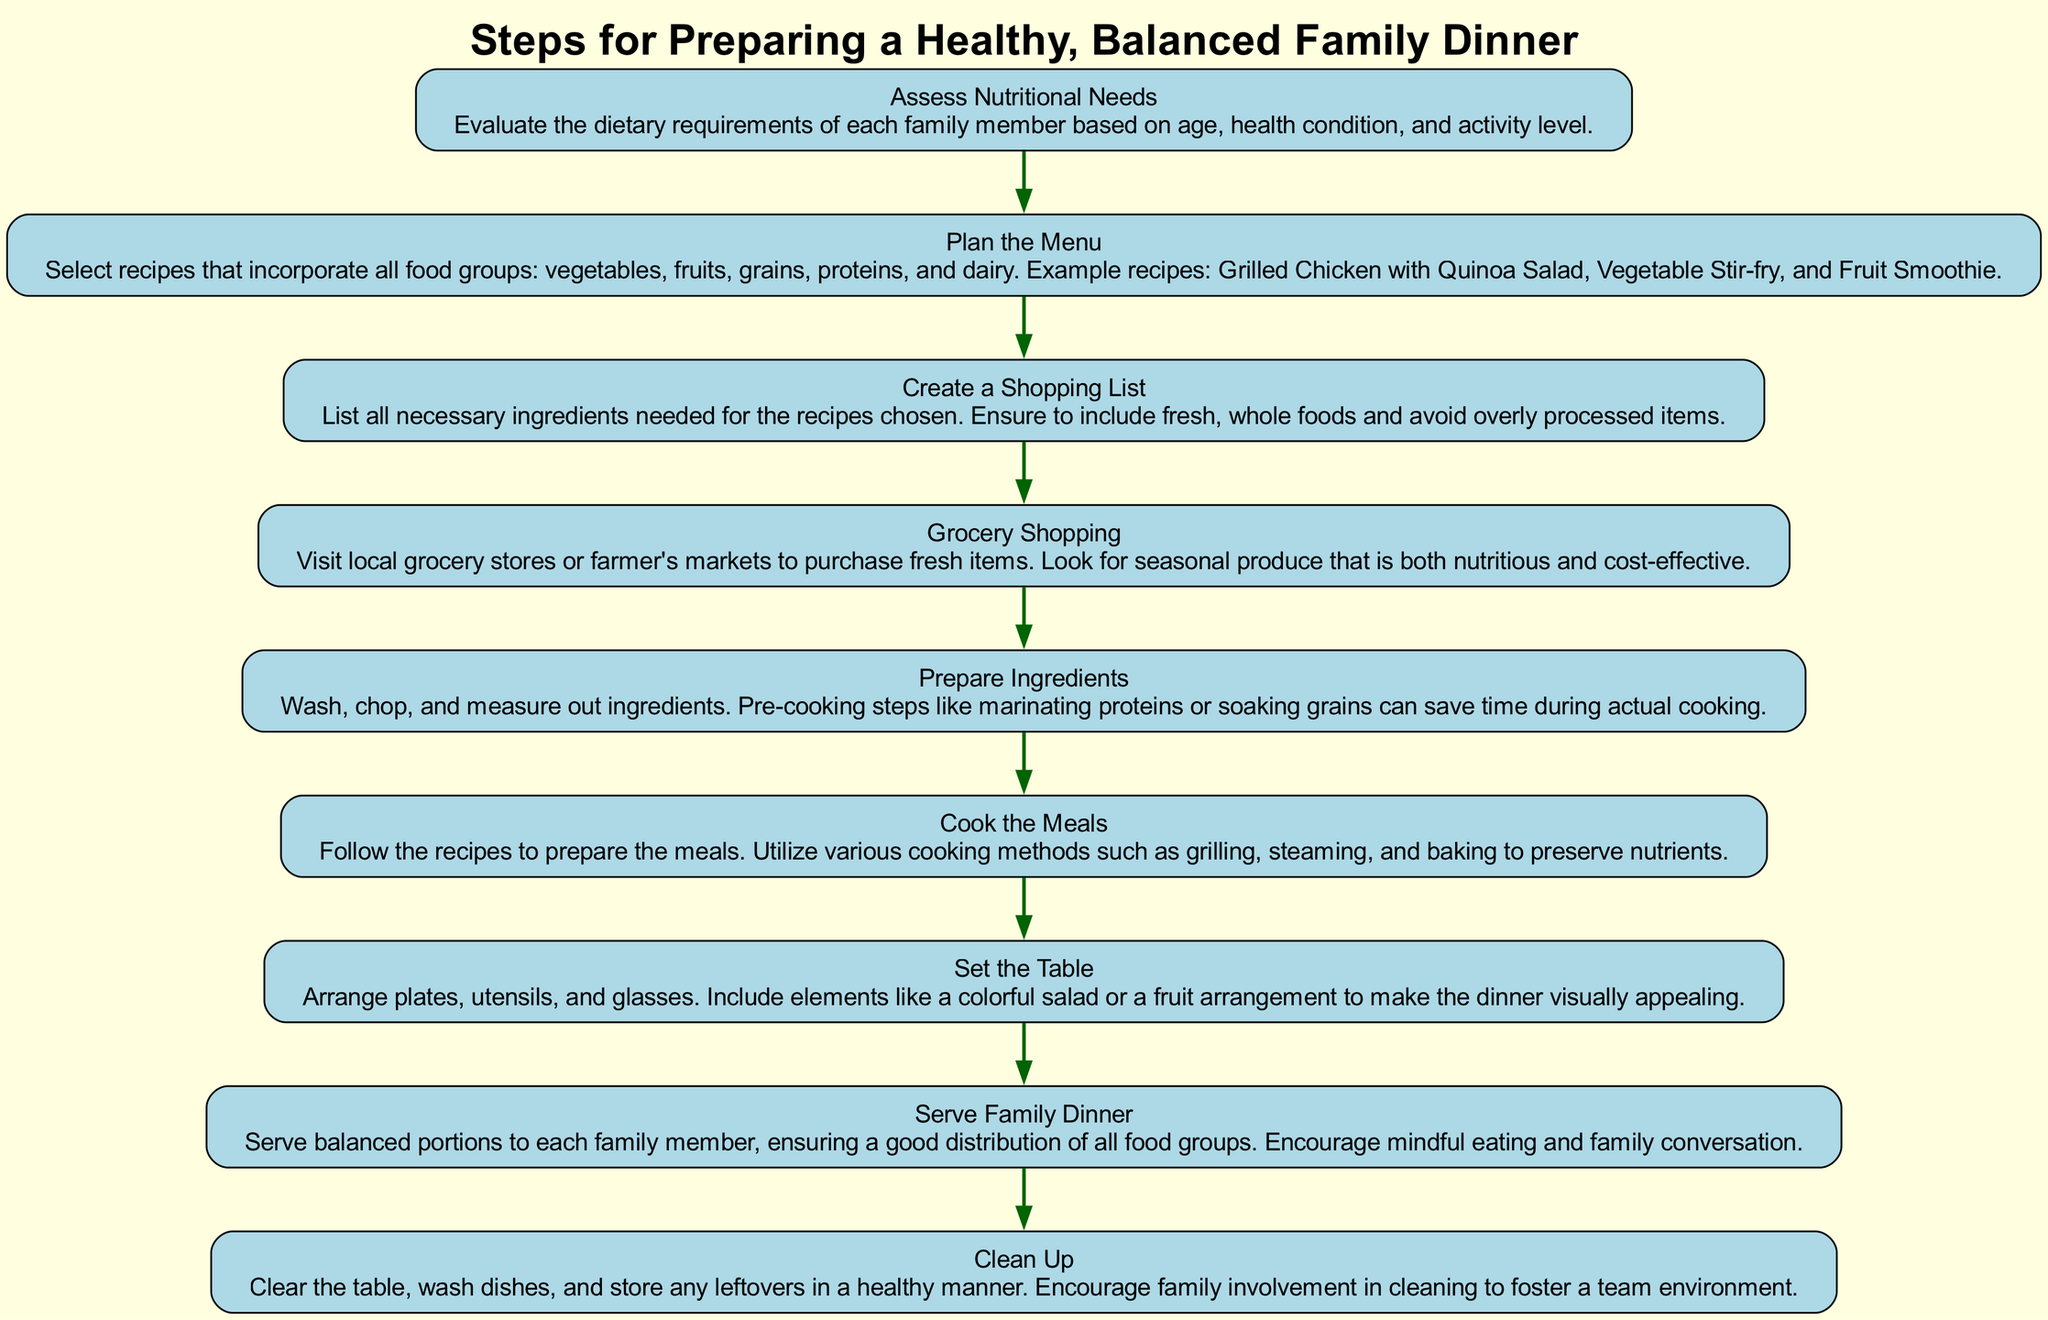What is the first step in the diagram? The first step listed in the diagram is "Assess Nutritional Needs." It is positioned at the top of the flow chart, indicating its priority as the starting point of the process.
Answer: Assess Nutritional Needs How many total steps are in the diagram? By counting the steps listed under "steps," we see there are eight distinct steps from assessing nutritional needs to cleaning up after dinner.
Answer: Eight Which step comes immediately after "Plan the Menu"? "Create a Shopping List" follows "Plan the Menu" directly in the sequence of the steps indicated in the flowchart.
Answer: Create a Shopping List What is the last step according to the flow chart? The last step noted in the diagram is "Clean Up," indicating it is the final activity after the meal has been served, underscoring the importance of maintaining a tidy environment.
Answer: Clean Up How do the steps transition from grocery shopping to cooking? The transition is made from "Grocery Shopping" to "Prepare Ingredients," which is directly followed by "Cook the Meals." This indicates that after retrieving groceries, the next logical step involves preparing the necessary ingredients before cooking.
Answer: Prepare Ingredients What combination of steps ensures a balanced family dinner? To ensure a balanced family dinner, one must engage in "Assess Nutritional Needs," "Plan the Menu," and "Serve Family Dinner," as these steps are critical in understanding dietary requirements and preparing balanced meals for everyone.
Answer: Assess Nutritional Needs, Plan the Menu, Serve Family Dinner How many ingredients should be included in the shopping list? The shopping list should include all necessary ingredients needed for the recipes chosen; this detail highlights the importance of being comprehensive in listing items without specifying a particular number.
Answer: All necessary ingredients What is a key focus during the "Serve Family Dinner" step? A key focus during this step is to "encourage mindful eating and family conversation,” suggesting that meals should be an opportunity for bonding rather than just eating.
Answer: Encourage mindful eating and family conversation 